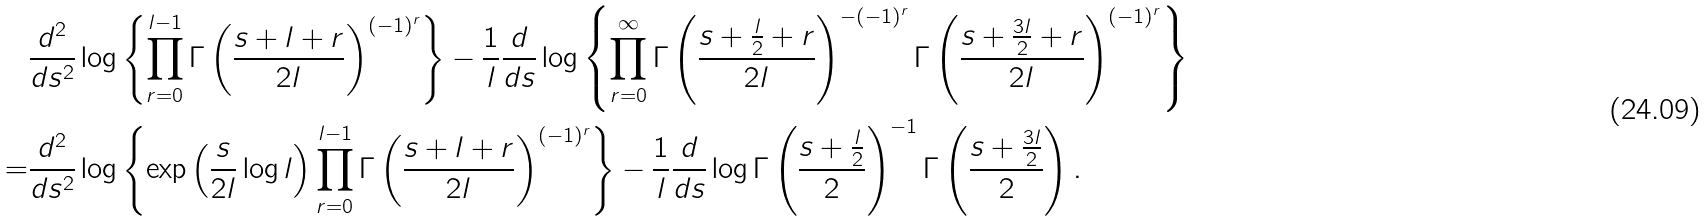Convert formula to latex. <formula><loc_0><loc_0><loc_500><loc_500>& \frac { d ^ { 2 } } { d s ^ { 2 } } \log \left \{ \prod _ { r = 0 } ^ { l - 1 } \Gamma \left ( \frac { s + l + r } { 2 l } \right ) ^ { ( - 1 ) ^ { r } } \right \} - \frac { 1 } { l } \frac { d } { d s } \log \left \{ \prod _ { r = 0 } ^ { \infty } \Gamma \left ( \frac { s + \frac { l } { 2 } + r } { 2 l } \right ) ^ { - ( - 1 ) ^ { r } } \Gamma \left ( \frac { s + \frac { 3 l } { 2 } + r } { 2 l } \right ) ^ { ( - 1 ) ^ { r } } \right \} \\ = & \frac { d ^ { 2 } } { d s ^ { 2 } } \log \left \{ \exp \left ( \frac { s } { 2 l } \log l \right ) \prod _ { r = 0 } ^ { l - 1 } \Gamma \left ( \frac { s + l + r } { 2 l } \right ) ^ { ( - 1 ) ^ { r } } \right \} - \frac { 1 } { l } \frac { d } { d s } \log \Gamma \left ( \frac { s + \frac { l } { 2 } } { 2 } \right ) ^ { - 1 } \Gamma \left ( \frac { s + \frac { 3 l } { 2 } } { 2 } \right ) .</formula> 